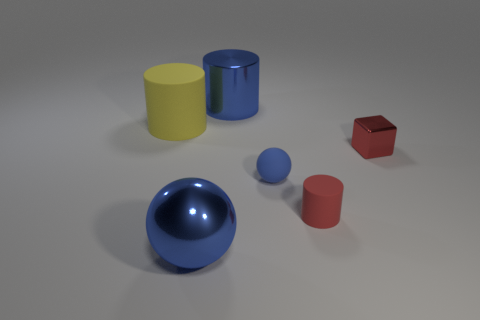Is there any other thing that is the same shape as the small red shiny thing?
Make the answer very short. No. There is a shiny object that is the same shape as the red matte object; what size is it?
Offer a terse response. Large. There is a tiny thing that is the same color as the big metal cylinder; what is it made of?
Ensure brevity in your answer.  Rubber. Is the number of blue balls less than the number of tiny blue metallic objects?
Offer a very short reply. No. There is a blue object right of the shiny cylinder; is its size the same as the matte cylinder that is on the left side of the blue metallic ball?
Offer a very short reply. No. How many objects are either red rubber spheres or large blue objects?
Offer a very short reply. 2. There is a red object on the right side of the red cylinder; how big is it?
Your answer should be compact. Small. What number of blue objects are to the right of the large metal object behind the blue shiny object in front of the blue matte object?
Keep it short and to the point. 1. Do the tiny metallic block and the tiny sphere have the same color?
Offer a terse response. No. How many rubber objects are to the left of the small red cylinder and in front of the cube?
Give a very brief answer. 1. 